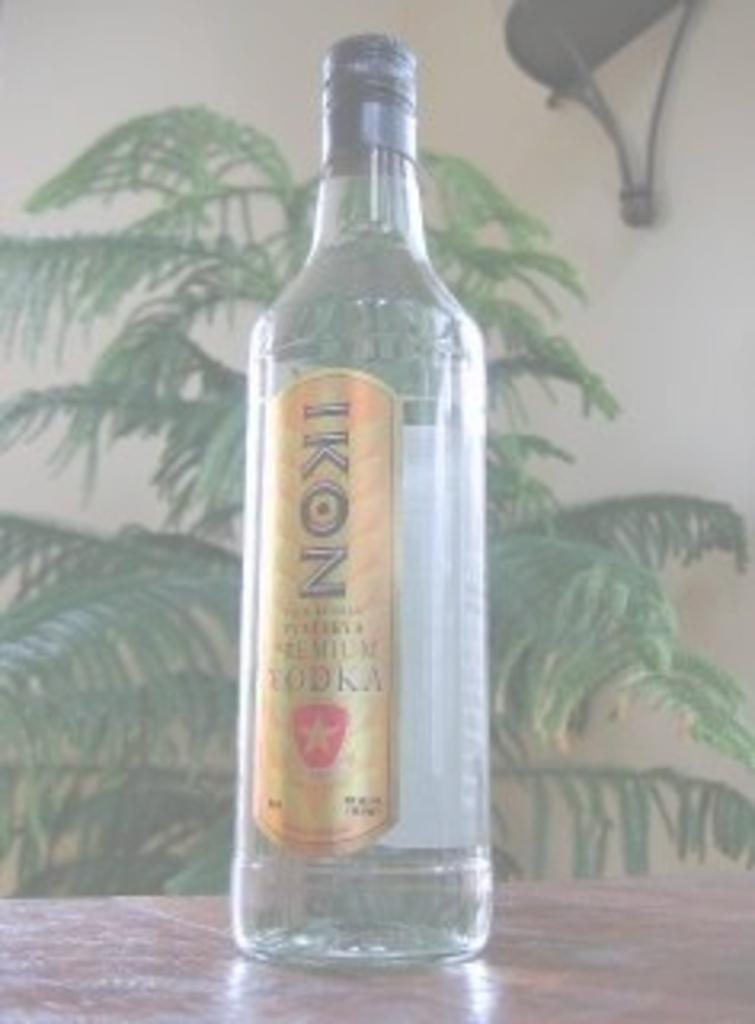What object is empty and visible in the image? There is an empty bottle in the image. Where is the empty bottle located? The bottle is placed on a table. What can be seen in the background of the image? There is a wall and a tree visible in the background of the image. What type of quiver is hanging on the wall in the image? There is no quiver present in the image; only a wall and a tree are visible in the background. 